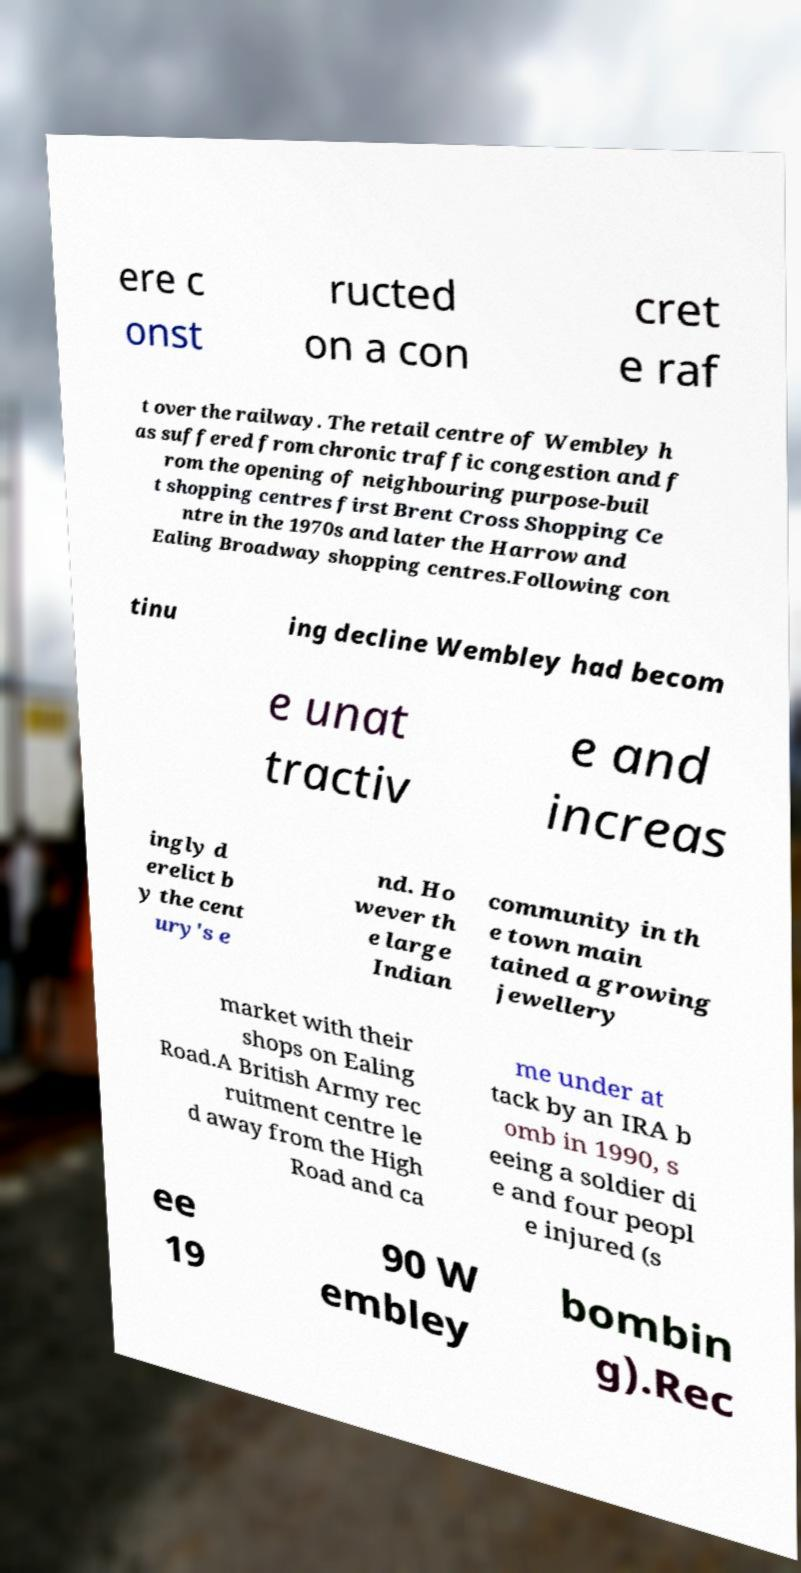What messages or text are displayed in this image? I need them in a readable, typed format. ere c onst ructed on a con cret e raf t over the railway. The retail centre of Wembley h as suffered from chronic traffic congestion and f rom the opening of neighbouring purpose-buil t shopping centres first Brent Cross Shopping Ce ntre in the 1970s and later the Harrow and Ealing Broadway shopping centres.Following con tinu ing decline Wembley had becom e unat tractiv e and increas ingly d erelict b y the cent ury's e nd. Ho wever th e large Indian community in th e town main tained a growing jewellery market with their shops on Ealing Road.A British Army rec ruitment centre le d away from the High Road and ca me under at tack by an IRA b omb in 1990, s eeing a soldier di e and four peopl e injured (s ee 19 90 W embley bombin g).Rec 